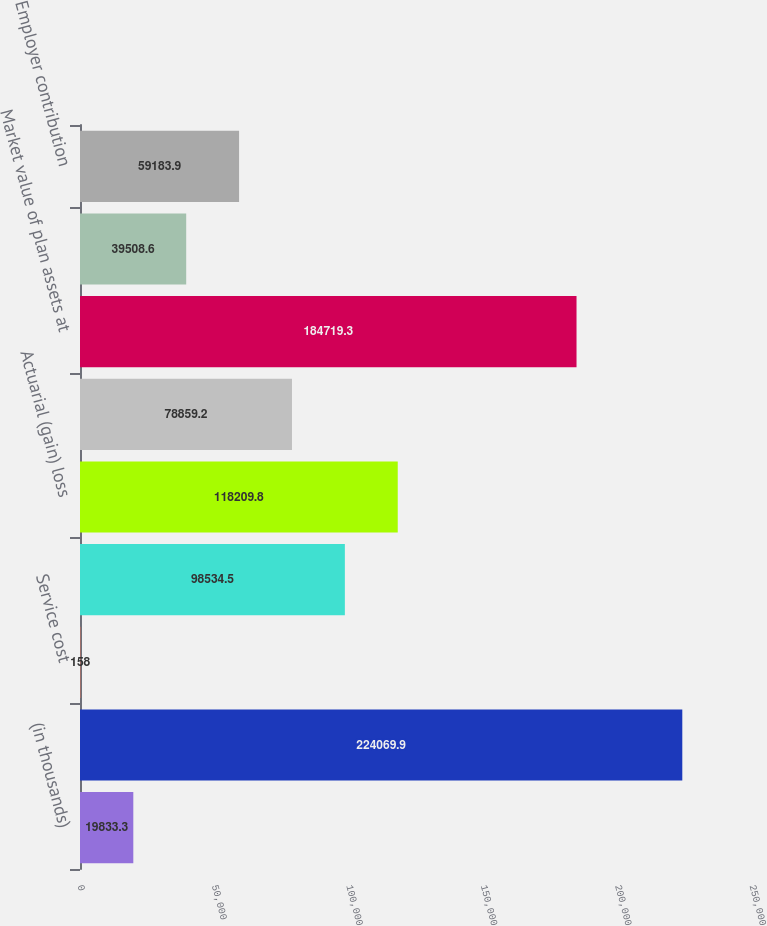Convert chart to OTSL. <chart><loc_0><loc_0><loc_500><loc_500><bar_chart><fcel>(in thousands)<fcel>Accumulated Benefit obligation<fcel>Service cost<fcel>Interest cost<fcel>Actuarial (gain) loss<fcel>Benefits paid<fcel>Market value of plan assets at<fcel>Actual return on plan assets<fcel>Employer contribution<nl><fcel>19833.3<fcel>224070<fcel>158<fcel>98534.5<fcel>118210<fcel>78859.2<fcel>184719<fcel>39508.6<fcel>59183.9<nl></chart> 